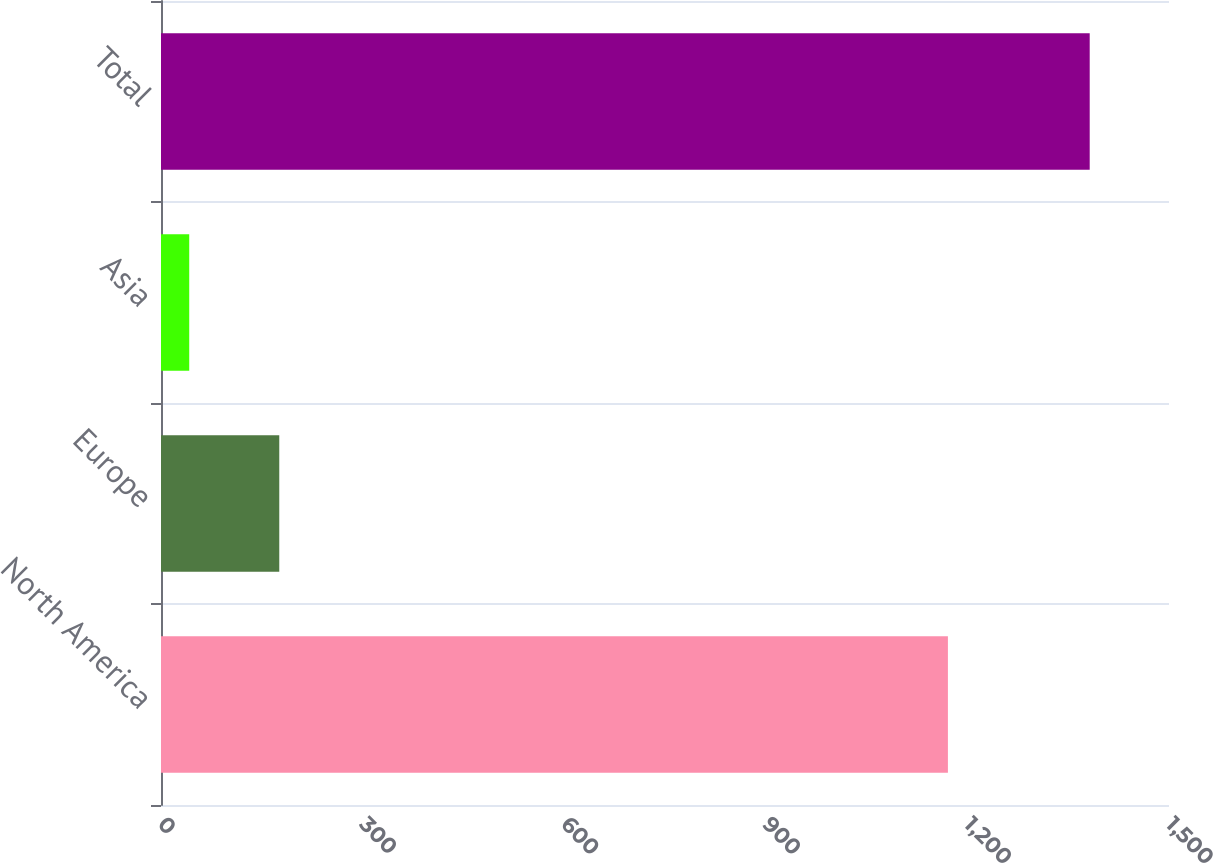Convert chart. <chart><loc_0><loc_0><loc_500><loc_500><bar_chart><fcel>North America<fcel>Europe<fcel>Asia<fcel>Total<nl><fcel>1171<fcel>176<fcel>42<fcel>1382<nl></chart> 